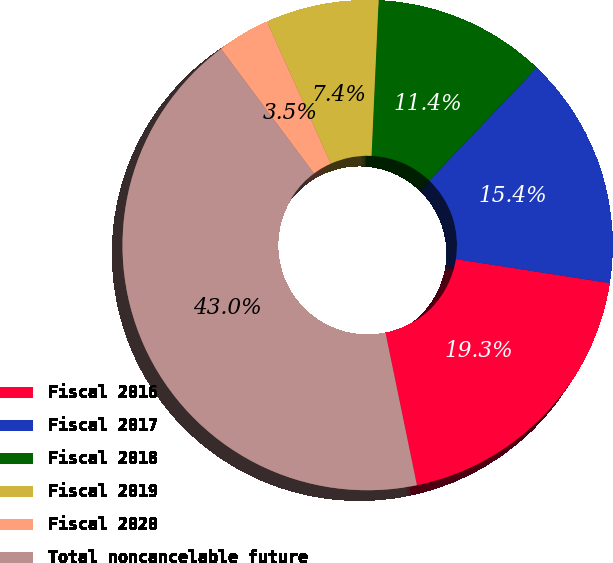Convert chart. <chart><loc_0><loc_0><loc_500><loc_500><pie_chart><fcel>Fiscal 2016<fcel>Fiscal 2017<fcel>Fiscal 2018<fcel>Fiscal 2019<fcel>Fiscal 2020<fcel>Total noncancelable future<nl><fcel>19.3%<fcel>15.35%<fcel>11.39%<fcel>7.44%<fcel>3.48%<fcel>43.04%<nl></chart> 